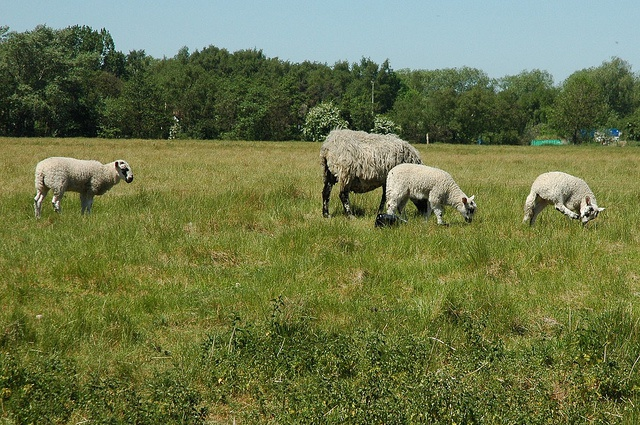Describe the objects in this image and their specific colors. I can see sheep in lightblue, darkgray, black, gray, and beige tones, sheep in lightblue, black, darkgray, tan, and darkgreen tones, sheep in lightblue, tan, darkgray, beige, and black tones, and sheep in lightblue, darkgray, beige, and gray tones in this image. 